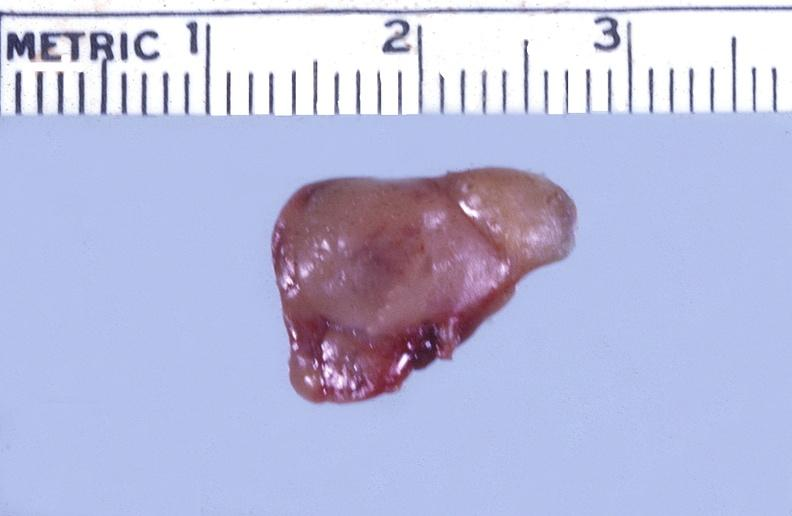what is present?
Answer the question using a single word or phrase. Endocrine 